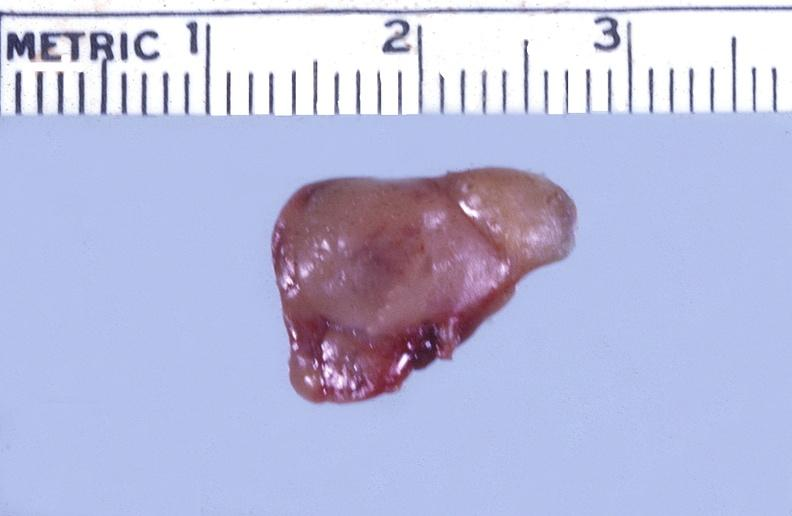what is present?
Answer the question using a single word or phrase. Endocrine 